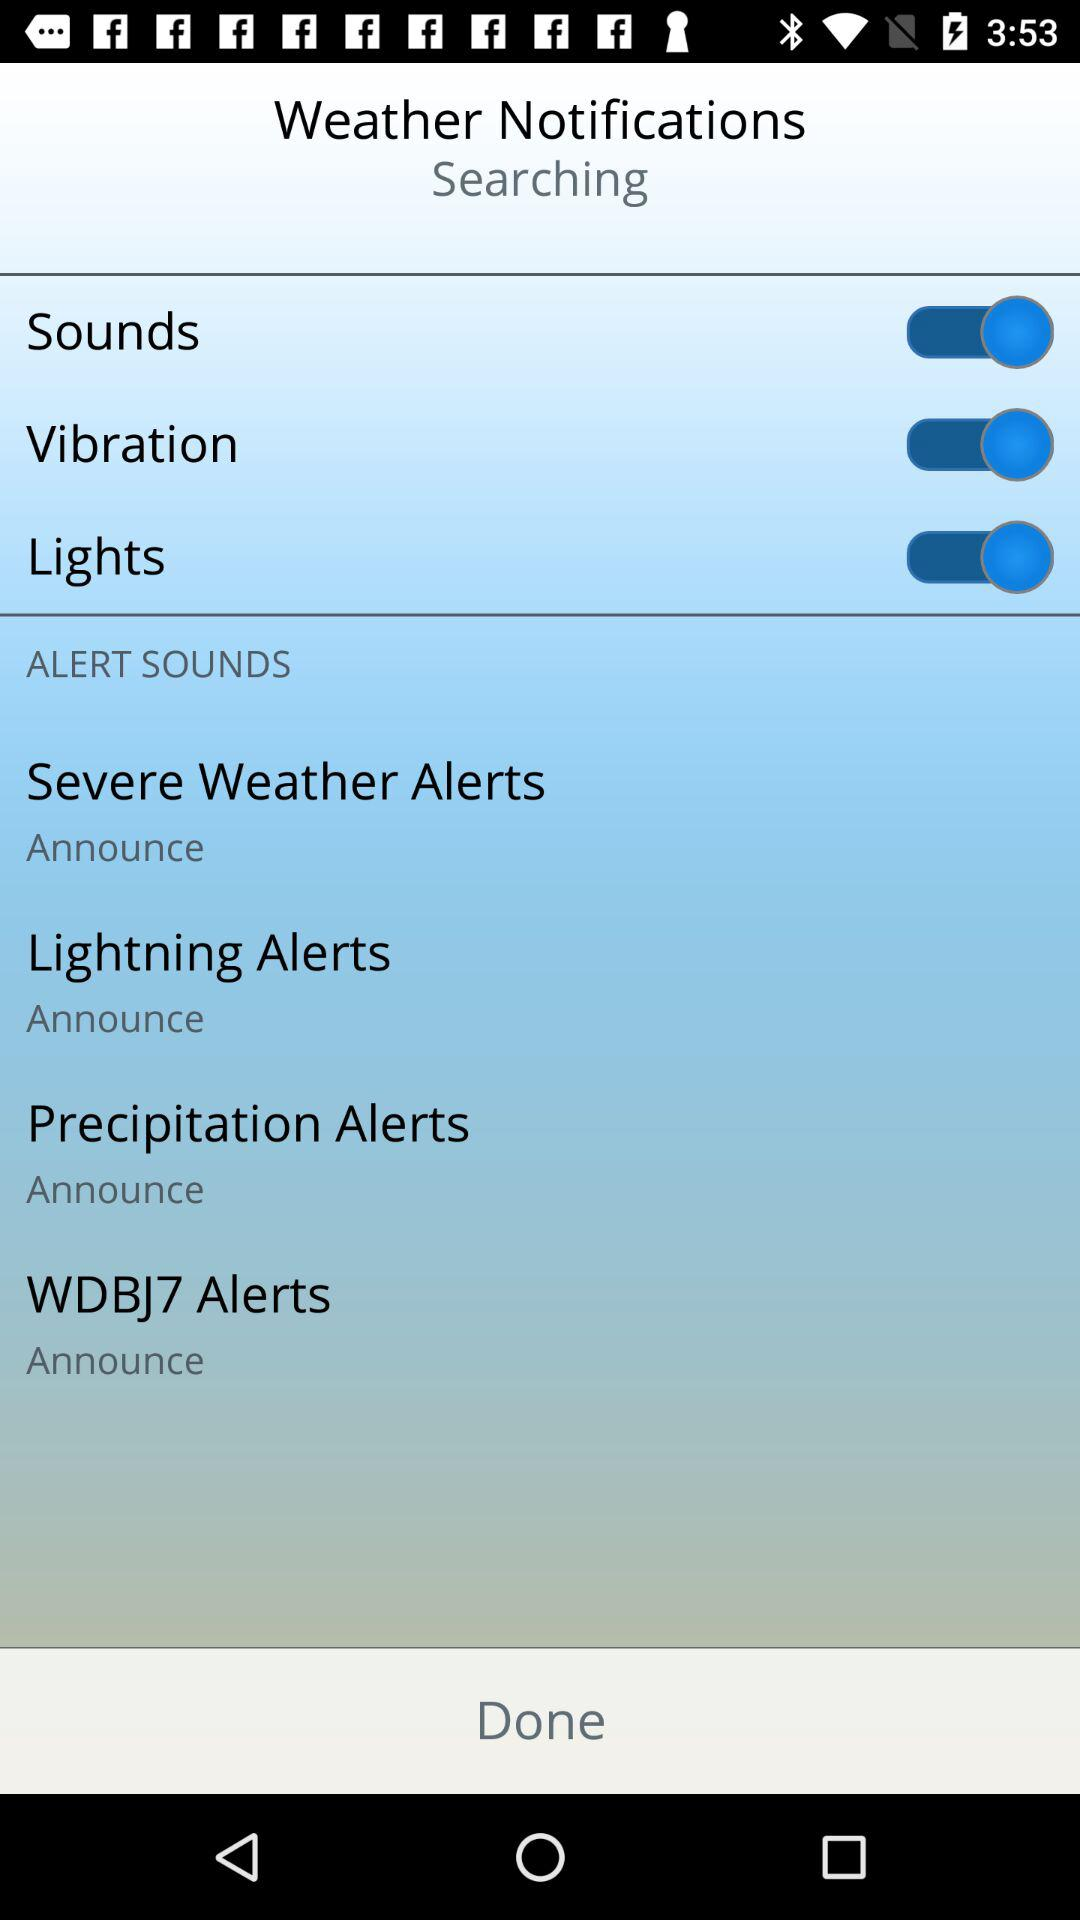How many alert sounds are there?
Answer the question using a single word or phrase. 4 